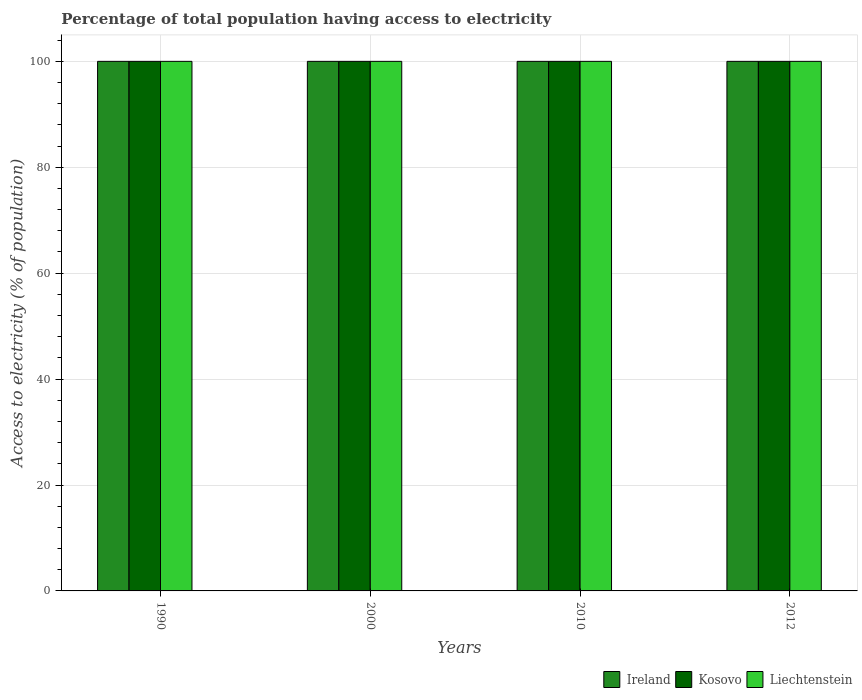How many groups of bars are there?
Provide a short and direct response. 4. Are the number of bars per tick equal to the number of legend labels?
Give a very brief answer. Yes. Are the number of bars on each tick of the X-axis equal?
Your answer should be very brief. Yes. How many bars are there on the 1st tick from the left?
Keep it short and to the point. 3. In how many cases, is the number of bars for a given year not equal to the number of legend labels?
Offer a very short reply. 0. What is the percentage of population that have access to electricity in Ireland in 2000?
Your answer should be very brief. 100. Across all years, what is the maximum percentage of population that have access to electricity in Liechtenstein?
Provide a succinct answer. 100. Across all years, what is the minimum percentage of population that have access to electricity in Liechtenstein?
Ensure brevity in your answer.  100. In which year was the percentage of population that have access to electricity in Kosovo maximum?
Keep it short and to the point. 1990. What is the total percentage of population that have access to electricity in Liechtenstein in the graph?
Make the answer very short. 400. What is the average percentage of population that have access to electricity in Kosovo per year?
Provide a succinct answer. 100. What is the ratio of the percentage of population that have access to electricity in Ireland in 1990 to that in 2010?
Provide a succinct answer. 1. Is the difference between the percentage of population that have access to electricity in Liechtenstein in 2000 and 2012 greater than the difference between the percentage of population that have access to electricity in Ireland in 2000 and 2012?
Offer a very short reply. No. What is the difference between the highest and the second highest percentage of population that have access to electricity in Liechtenstein?
Give a very brief answer. 0. What is the difference between the highest and the lowest percentage of population that have access to electricity in Kosovo?
Provide a succinct answer. 0. In how many years, is the percentage of population that have access to electricity in Liechtenstein greater than the average percentage of population that have access to electricity in Liechtenstein taken over all years?
Your response must be concise. 0. What does the 1st bar from the left in 1990 represents?
Offer a terse response. Ireland. What does the 2nd bar from the right in 2012 represents?
Your answer should be compact. Kosovo. Are all the bars in the graph horizontal?
Keep it short and to the point. No. What is the difference between two consecutive major ticks on the Y-axis?
Keep it short and to the point. 20. Does the graph contain any zero values?
Provide a succinct answer. No. How many legend labels are there?
Provide a short and direct response. 3. How are the legend labels stacked?
Ensure brevity in your answer.  Horizontal. What is the title of the graph?
Offer a very short reply. Percentage of total population having access to electricity. Does "Peru" appear as one of the legend labels in the graph?
Your answer should be very brief. No. What is the label or title of the Y-axis?
Give a very brief answer. Access to electricity (% of population). What is the Access to electricity (% of population) of Ireland in 1990?
Provide a succinct answer. 100. What is the Access to electricity (% of population) of Kosovo in 1990?
Your response must be concise. 100. What is the Access to electricity (% of population) in Kosovo in 2000?
Provide a succinct answer. 100. What is the Access to electricity (% of population) in Ireland in 2010?
Offer a very short reply. 100. What is the Access to electricity (% of population) of Ireland in 2012?
Provide a succinct answer. 100. What is the Access to electricity (% of population) in Kosovo in 2012?
Offer a very short reply. 100. What is the Access to electricity (% of population) in Liechtenstein in 2012?
Provide a short and direct response. 100. Across all years, what is the maximum Access to electricity (% of population) in Kosovo?
Your answer should be compact. 100. Across all years, what is the maximum Access to electricity (% of population) of Liechtenstein?
Provide a succinct answer. 100. Across all years, what is the minimum Access to electricity (% of population) in Ireland?
Keep it short and to the point. 100. Across all years, what is the minimum Access to electricity (% of population) of Kosovo?
Offer a terse response. 100. Across all years, what is the minimum Access to electricity (% of population) in Liechtenstein?
Provide a succinct answer. 100. What is the total Access to electricity (% of population) in Liechtenstein in the graph?
Offer a very short reply. 400. What is the difference between the Access to electricity (% of population) of Kosovo in 1990 and that in 2000?
Offer a terse response. 0. What is the difference between the Access to electricity (% of population) of Ireland in 1990 and that in 2010?
Make the answer very short. 0. What is the difference between the Access to electricity (% of population) in Liechtenstein in 1990 and that in 2010?
Your response must be concise. 0. What is the difference between the Access to electricity (% of population) in Kosovo in 1990 and that in 2012?
Offer a very short reply. 0. What is the difference between the Access to electricity (% of population) in Liechtenstein in 2000 and that in 2010?
Keep it short and to the point. 0. What is the difference between the Access to electricity (% of population) in Ireland in 2000 and that in 2012?
Offer a very short reply. 0. What is the difference between the Access to electricity (% of population) in Kosovo in 2000 and that in 2012?
Your answer should be very brief. 0. What is the difference between the Access to electricity (% of population) of Liechtenstein in 2010 and that in 2012?
Make the answer very short. 0. What is the difference between the Access to electricity (% of population) of Kosovo in 1990 and the Access to electricity (% of population) of Liechtenstein in 2000?
Provide a short and direct response. 0. What is the difference between the Access to electricity (% of population) of Kosovo in 1990 and the Access to electricity (% of population) of Liechtenstein in 2010?
Provide a short and direct response. 0. What is the difference between the Access to electricity (% of population) in Ireland in 1990 and the Access to electricity (% of population) in Liechtenstein in 2012?
Provide a short and direct response. 0. What is the difference between the Access to electricity (% of population) of Ireland in 2000 and the Access to electricity (% of population) of Kosovo in 2010?
Provide a short and direct response. 0. What is the difference between the Access to electricity (% of population) in Ireland in 2000 and the Access to electricity (% of population) in Liechtenstein in 2010?
Offer a terse response. 0. What is the difference between the Access to electricity (% of population) of Kosovo in 2000 and the Access to electricity (% of population) of Liechtenstein in 2010?
Provide a short and direct response. 0. What is the difference between the Access to electricity (% of population) in Ireland in 2000 and the Access to electricity (% of population) in Liechtenstein in 2012?
Make the answer very short. 0. What is the difference between the Access to electricity (% of population) in Kosovo in 2010 and the Access to electricity (% of population) in Liechtenstein in 2012?
Make the answer very short. 0. What is the average Access to electricity (% of population) in Kosovo per year?
Your answer should be very brief. 100. What is the average Access to electricity (% of population) of Liechtenstein per year?
Ensure brevity in your answer.  100. In the year 2000, what is the difference between the Access to electricity (% of population) in Ireland and Access to electricity (% of population) in Liechtenstein?
Offer a terse response. 0. In the year 2010, what is the difference between the Access to electricity (% of population) in Ireland and Access to electricity (% of population) in Kosovo?
Keep it short and to the point. 0. In the year 2010, what is the difference between the Access to electricity (% of population) in Ireland and Access to electricity (% of population) in Liechtenstein?
Your answer should be very brief. 0. In the year 2010, what is the difference between the Access to electricity (% of population) in Kosovo and Access to electricity (% of population) in Liechtenstein?
Offer a very short reply. 0. In the year 2012, what is the difference between the Access to electricity (% of population) in Kosovo and Access to electricity (% of population) in Liechtenstein?
Your answer should be very brief. 0. What is the ratio of the Access to electricity (% of population) in Liechtenstein in 1990 to that in 2010?
Your answer should be compact. 1. What is the ratio of the Access to electricity (% of population) of Ireland in 1990 to that in 2012?
Your response must be concise. 1. What is the ratio of the Access to electricity (% of population) of Ireland in 2000 to that in 2010?
Offer a terse response. 1. What is the ratio of the Access to electricity (% of population) of Liechtenstein in 2000 to that in 2010?
Offer a very short reply. 1. What is the ratio of the Access to electricity (% of population) in Liechtenstein in 2000 to that in 2012?
Provide a short and direct response. 1. What is the ratio of the Access to electricity (% of population) of Ireland in 2010 to that in 2012?
Keep it short and to the point. 1. What is the difference between the highest and the lowest Access to electricity (% of population) in Ireland?
Provide a short and direct response. 0. What is the difference between the highest and the lowest Access to electricity (% of population) in Kosovo?
Your response must be concise. 0. What is the difference between the highest and the lowest Access to electricity (% of population) in Liechtenstein?
Ensure brevity in your answer.  0. 